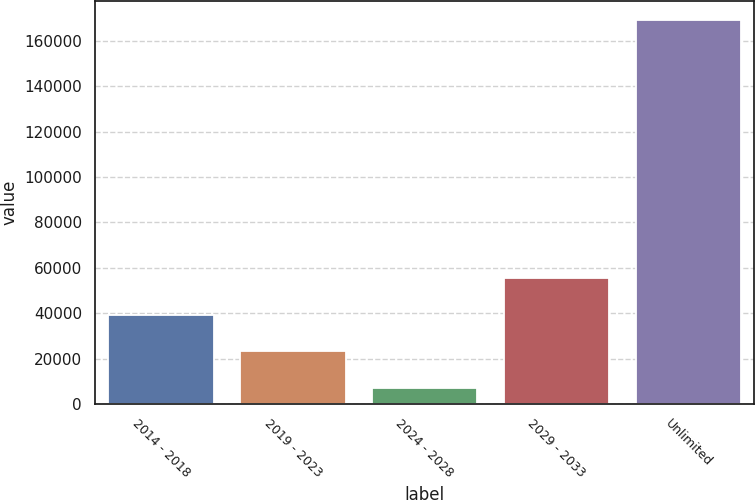Convert chart to OTSL. <chart><loc_0><loc_0><loc_500><loc_500><bar_chart><fcel>2014 - 2018<fcel>2019 - 2023<fcel>2024 - 2028<fcel>2029 - 2033<fcel>Unlimited<nl><fcel>39429.4<fcel>23205.2<fcel>6981<fcel>55653.6<fcel>169223<nl></chart> 